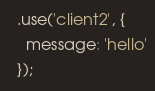Convert code to text. <code><loc_0><loc_0><loc_500><loc_500><_JavaScript_>  .use('client2', {
    message: 'hello'
  });
</code> 